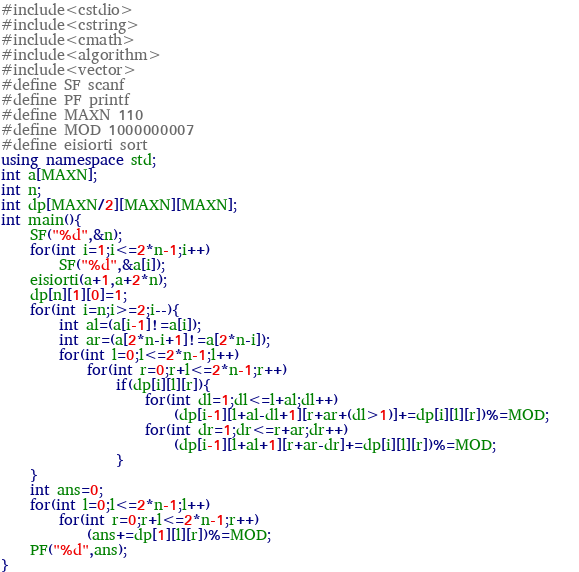Convert code to text. <code><loc_0><loc_0><loc_500><loc_500><_C++_>#include<cstdio>
#include<cstring>
#include<cmath>
#include<algorithm>
#include<vector>
#define SF scanf
#define PF printf
#define MAXN 110
#define MOD 1000000007
#define eisiorti sort
using namespace std;
int a[MAXN];
int n;
int dp[MAXN/2][MAXN][MAXN];
int main(){
	SF("%d",&n);
	for(int i=1;i<=2*n-1;i++)
		SF("%d",&a[i]);
	eisiorti(a+1,a+2*n);
	dp[n][1][0]=1;
	for(int i=n;i>=2;i--){
		int al=(a[i-1]!=a[i]);
		int ar=(a[2*n-i+1]!=a[2*n-i]);
		for(int l=0;l<=2*n-1;l++)
			for(int r=0;r+l<=2*n-1;r++)
				if(dp[i][l][r]){
					for(int dl=1;dl<=l+al;dl++)
						(dp[i-1][l+al-dl+1][r+ar+(dl>1)]+=dp[i][l][r])%=MOD;	
					for(int dr=1;dr<=r+ar;dr++)
						(dp[i-1][l+al+1][r+ar-dr]+=dp[i][l][r])%=MOD;	
				}
	}
	int ans=0;
	for(int l=0;l<=2*n-1;l++)
		for(int r=0;r+l<=2*n-1;r++)
			(ans+=dp[1][l][r])%=MOD;
	PF("%d",ans);
}</code> 